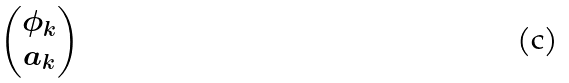<formula> <loc_0><loc_0><loc_500><loc_500>\begin{pmatrix} \phi _ { k } \\ a _ { k } \end{pmatrix}</formula> 